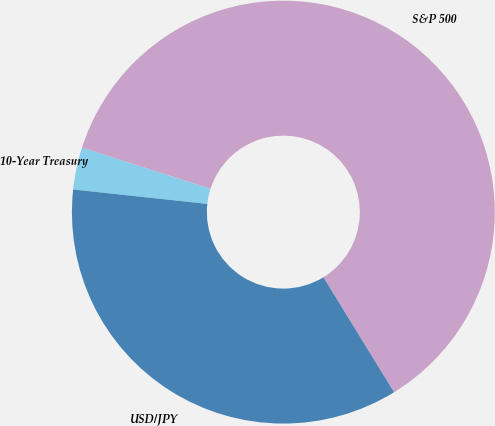Convert chart. <chart><loc_0><loc_0><loc_500><loc_500><pie_chart><fcel>10-Year Treasury<fcel>S&P 500<fcel>USD/JPY<nl><fcel>3.23%<fcel>61.29%<fcel>35.48%<nl></chart> 